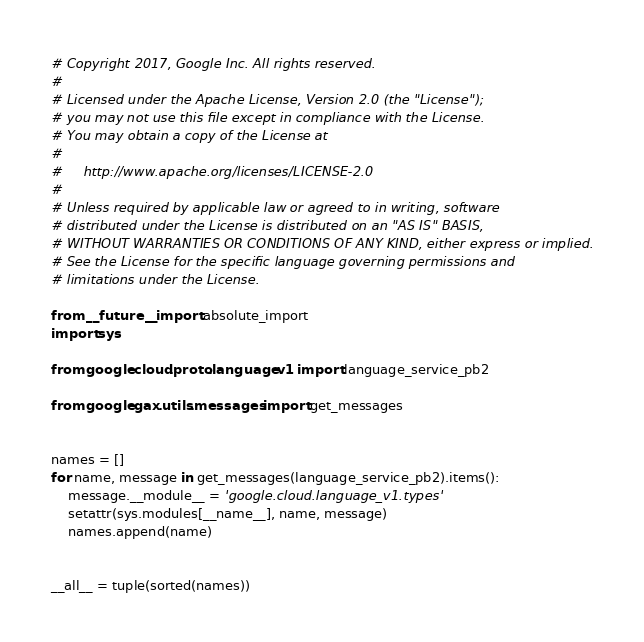<code> <loc_0><loc_0><loc_500><loc_500><_Python_># Copyright 2017, Google Inc. All rights reserved.
#
# Licensed under the Apache License, Version 2.0 (the "License");
# you may not use this file except in compliance with the License.
# You may obtain a copy of the License at
#
#     http://www.apache.org/licenses/LICENSE-2.0
#
# Unless required by applicable law or agreed to in writing, software
# distributed under the License is distributed on an "AS IS" BASIS,
# WITHOUT WARRANTIES OR CONDITIONS OF ANY KIND, either express or implied.
# See the License for the specific language governing permissions and
# limitations under the License.

from __future__ import absolute_import
import sys

from google.cloud.proto.language.v1 import language_service_pb2

from google.gax.utils.messages import get_messages


names = []
for name, message in get_messages(language_service_pb2).items():
    message.__module__ = 'google.cloud.language_v1.types'
    setattr(sys.modules[__name__], name, message)
    names.append(name)


__all__ = tuple(sorted(names))
</code> 